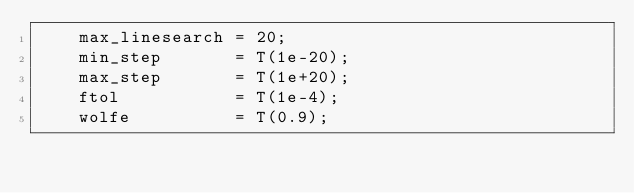<code> <loc_0><loc_0><loc_500><loc_500><_Cuda_>    max_linesearch = 20;
    min_step       = T(1e-20);
    max_step       = T(1e+20);
    ftol           = T(1e-4);
    wolfe          = T(0.9);</code> 